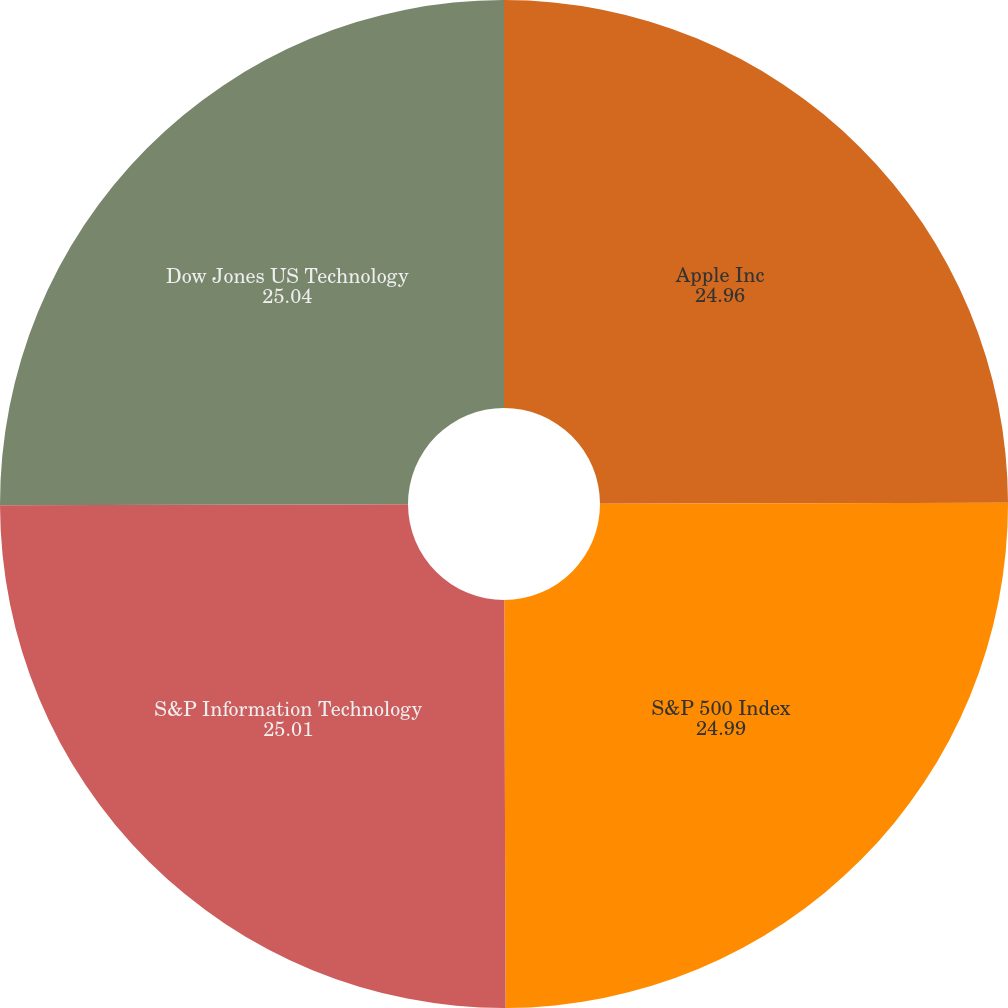<chart> <loc_0><loc_0><loc_500><loc_500><pie_chart><fcel>Apple Inc<fcel>S&P 500 Index<fcel>S&P Information Technology<fcel>Dow Jones US Technology<nl><fcel>24.96%<fcel>24.99%<fcel>25.01%<fcel>25.04%<nl></chart> 